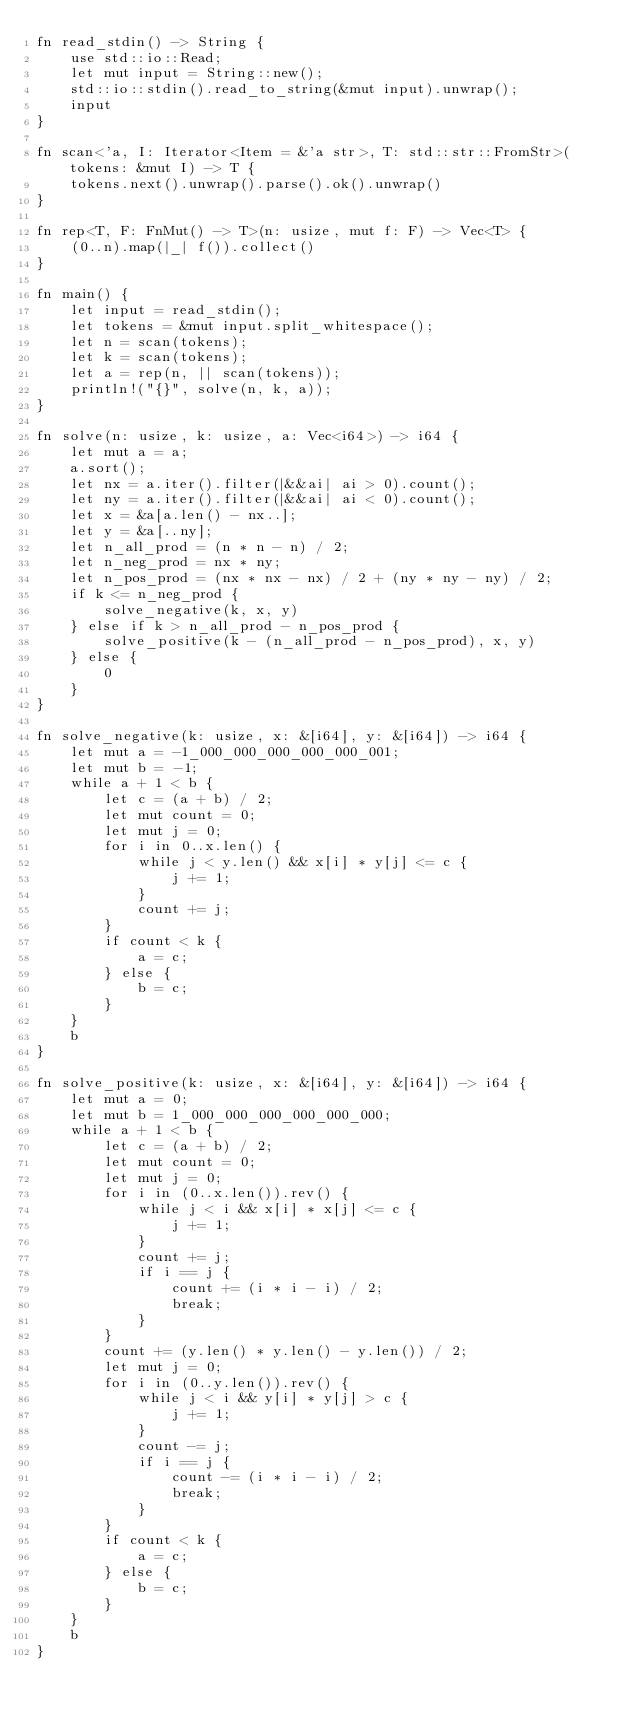Convert code to text. <code><loc_0><loc_0><loc_500><loc_500><_Rust_>fn read_stdin() -> String {
    use std::io::Read;
    let mut input = String::new();
    std::io::stdin().read_to_string(&mut input).unwrap();
    input
}

fn scan<'a, I: Iterator<Item = &'a str>, T: std::str::FromStr>(tokens: &mut I) -> T {
    tokens.next().unwrap().parse().ok().unwrap()
}

fn rep<T, F: FnMut() -> T>(n: usize, mut f: F) -> Vec<T> {
    (0..n).map(|_| f()).collect()
}

fn main() {
    let input = read_stdin();
    let tokens = &mut input.split_whitespace();
    let n = scan(tokens);
    let k = scan(tokens);
    let a = rep(n, || scan(tokens));
    println!("{}", solve(n, k, a));
}

fn solve(n: usize, k: usize, a: Vec<i64>) -> i64 {
    let mut a = a;
    a.sort();
    let nx = a.iter().filter(|&&ai| ai > 0).count();
    let ny = a.iter().filter(|&&ai| ai < 0).count();
    let x = &a[a.len() - nx..];
    let y = &a[..ny];
    let n_all_prod = (n * n - n) / 2;
    let n_neg_prod = nx * ny;
    let n_pos_prod = (nx * nx - nx) / 2 + (ny * ny - ny) / 2;
    if k <= n_neg_prod {
        solve_negative(k, x, y)
    } else if k > n_all_prod - n_pos_prod {
        solve_positive(k - (n_all_prod - n_pos_prod), x, y)
    } else {
        0
    }
}

fn solve_negative(k: usize, x: &[i64], y: &[i64]) -> i64 {
    let mut a = -1_000_000_000_000_000_001;
    let mut b = -1;
    while a + 1 < b {
        let c = (a + b) / 2;
        let mut count = 0;
        let mut j = 0;
        for i in 0..x.len() {
            while j < y.len() && x[i] * y[j] <= c {
                j += 1;
            }
            count += j;
        }
        if count < k {
            a = c;
        } else {
            b = c;
        }
    }
    b
}

fn solve_positive(k: usize, x: &[i64], y: &[i64]) -> i64 {
    let mut a = 0;
    let mut b = 1_000_000_000_000_000_000;
    while a + 1 < b {
        let c = (a + b) / 2;
        let mut count = 0;
        let mut j = 0;
        for i in (0..x.len()).rev() {
            while j < i && x[i] * x[j] <= c {
                j += 1;
            }
            count += j;
            if i == j {
                count += (i * i - i) / 2;
                break;
            }
        }
        count += (y.len() * y.len() - y.len()) / 2;
        let mut j = 0;
        for i in (0..y.len()).rev() {
            while j < i && y[i] * y[j] > c {
                j += 1;
            }
            count -= j;
            if i == j {
                count -= (i * i - i) / 2;
                break;
            }
        }
        if count < k {
            a = c;
        } else {
            b = c;
        }
    }
    b
}</code> 